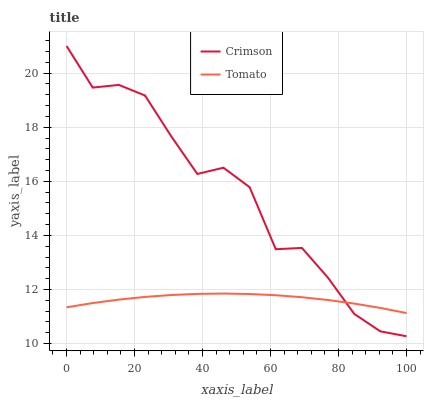Does Tomato have the minimum area under the curve?
Answer yes or no. Yes. Does Crimson have the maximum area under the curve?
Answer yes or no. Yes. Does Tomato have the maximum area under the curve?
Answer yes or no. No. Is Tomato the smoothest?
Answer yes or no. Yes. Is Crimson the roughest?
Answer yes or no. Yes. Is Tomato the roughest?
Answer yes or no. No. Does Tomato have the lowest value?
Answer yes or no. No. Does Tomato have the highest value?
Answer yes or no. No. 